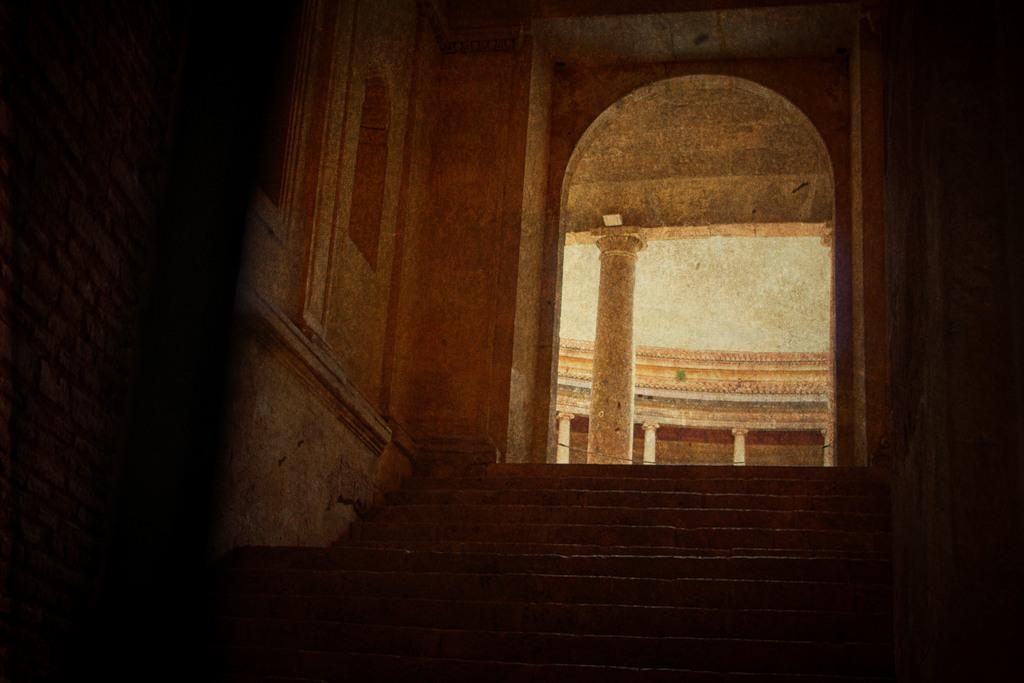What architectural feature is located at the front of the image? There are stairs in the front of the image. What can be seen in the center of the image? There is an arch in the center of the image. What is present at the back of the image? There are pillars at the back of the image. What is visible on the left side of the image? There is a window on the left side of the image. How does the love between the two characters in the image manifest itself? There are no characters or any indication of love in the image; it features stairs, an arch, pillars, and a window. What is the relation between the pillars and the window in the image? The pillars and the window are separate architectural features in the image, and there is no direct relation between them. 